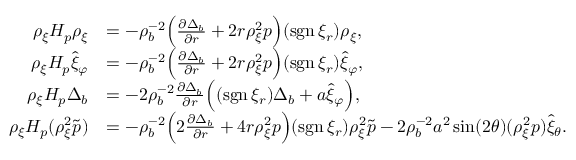<formula> <loc_0><loc_0><loc_500><loc_500>\begin{array} { r l } { \rho _ { \xi } H _ { p } \rho _ { \xi } } & { = - \rho _ { b } ^ { - 2 } \left ( \frac { \partial \Delta _ { b } } { \partial r } + 2 r \rho _ { \xi } ^ { 2 } p \right ) ( s g n \, \xi _ { r } ) \rho _ { \xi } , } \\ { \rho _ { \xi } H _ { p } \hat { \xi } _ { \varphi } } & { = - \rho _ { b } ^ { - 2 } \left ( \frac { \partial \Delta _ { b } } { \partial r } + 2 r \rho _ { \xi } ^ { 2 } p \right ) ( s g n \, \xi _ { r } ) \hat { \xi } _ { \varphi } , } \\ { \rho _ { \xi } H _ { p } \Delta _ { b } } & { = - 2 \rho _ { b } ^ { - 2 } \frac { \partial \Delta _ { b } } { \partial r } \left ( ( s g n \, \xi _ { r } ) \Delta _ { b } + a \hat { \xi } _ { \varphi } \right ) , } \\ { \rho _ { \xi } H _ { p } ( \rho _ { \xi } ^ { 2 } \tilde { p } ) } & { = - \rho _ { b } ^ { - 2 } \left ( 2 \frac { \partial \Delta _ { b } } { \partial r } + 4 r \rho _ { \xi } ^ { 2 } p \right ) ( s g n \, \xi _ { r } ) \rho _ { \xi } ^ { 2 } \tilde { p } - 2 \rho _ { b } ^ { - 2 } a ^ { 2 } \sin ( 2 \theta ) ( \rho _ { \xi } ^ { 2 } p ) \hat { \xi } _ { \theta } . } \end{array}</formula> 